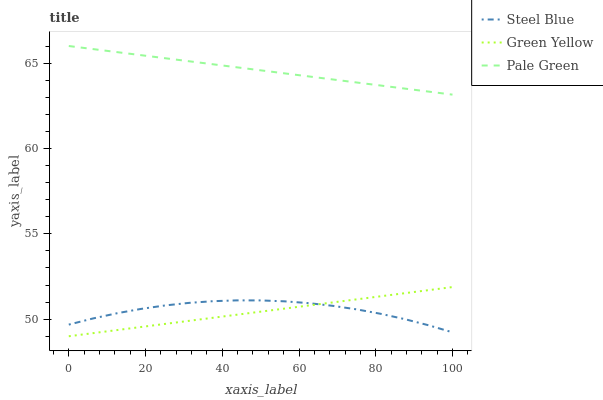Does Green Yellow have the minimum area under the curve?
Answer yes or no. Yes. Does Pale Green have the maximum area under the curve?
Answer yes or no. Yes. Does Steel Blue have the minimum area under the curve?
Answer yes or no. No. Does Steel Blue have the maximum area under the curve?
Answer yes or no. No. Is Green Yellow the smoothest?
Answer yes or no. Yes. Is Steel Blue the roughest?
Answer yes or no. Yes. Is Steel Blue the smoothest?
Answer yes or no. No. Is Green Yellow the roughest?
Answer yes or no. No. Does Green Yellow have the lowest value?
Answer yes or no. Yes. Does Steel Blue have the lowest value?
Answer yes or no. No. Does Pale Green have the highest value?
Answer yes or no. Yes. Does Green Yellow have the highest value?
Answer yes or no. No. Is Steel Blue less than Pale Green?
Answer yes or no. Yes. Is Pale Green greater than Green Yellow?
Answer yes or no. Yes. Does Steel Blue intersect Green Yellow?
Answer yes or no. Yes. Is Steel Blue less than Green Yellow?
Answer yes or no. No. Is Steel Blue greater than Green Yellow?
Answer yes or no. No. Does Steel Blue intersect Pale Green?
Answer yes or no. No. 